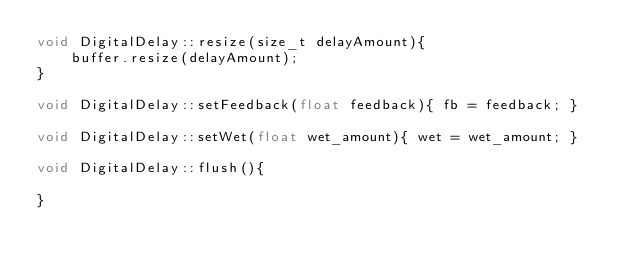<code> <loc_0><loc_0><loc_500><loc_500><_C++_>void DigitalDelay::resize(size_t delayAmount){
    buffer.resize(delayAmount);
}

void DigitalDelay::setFeedback(float feedback){ fb = feedback; }

void DigitalDelay::setWet(float wet_amount){ wet = wet_amount; }

void DigitalDelay::flush(){
    
}</code> 